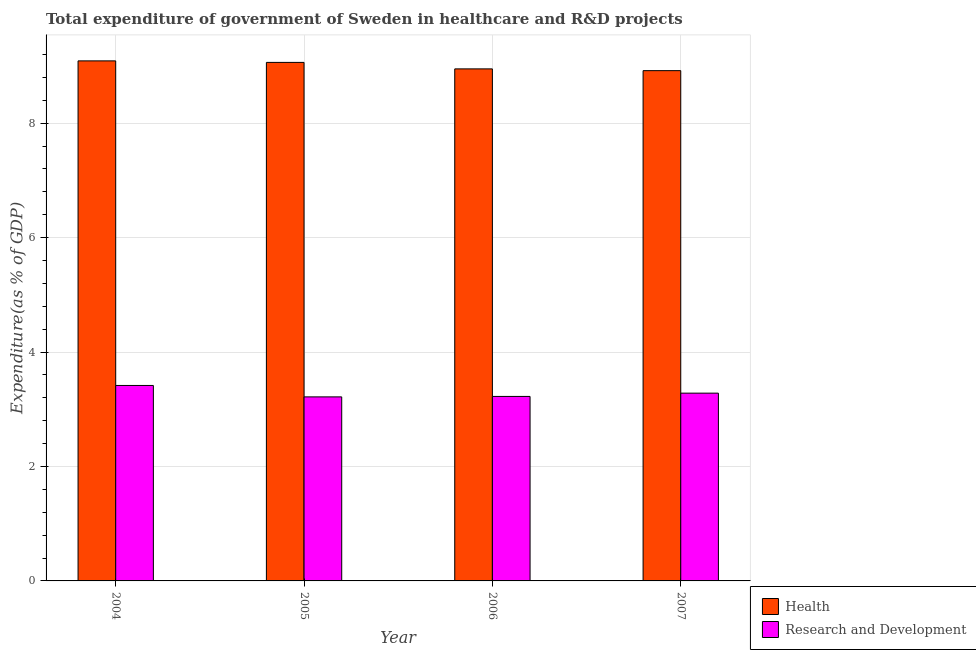How many different coloured bars are there?
Make the answer very short. 2. How many groups of bars are there?
Make the answer very short. 4. Are the number of bars per tick equal to the number of legend labels?
Provide a succinct answer. Yes. How many bars are there on the 3rd tick from the left?
Your response must be concise. 2. How many bars are there on the 4th tick from the right?
Provide a short and direct response. 2. What is the label of the 3rd group of bars from the left?
Offer a very short reply. 2006. In how many cases, is the number of bars for a given year not equal to the number of legend labels?
Give a very brief answer. 0. What is the expenditure in healthcare in 2005?
Make the answer very short. 9.06. Across all years, what is the maximum expenditure in healthcare?
Offer a terse response. 9.09. Across all years, what is the minimum expenditure in healthcare?
Ensure brevity in your answer.  8.92. In which year was the expenditure in r&d maximum?
Make the answer very short. 2004. In which year was the expenditure in healthcare minimum?
Your answer should be compact. 2007. What is the total expenditure in r&d in the graph?
Provide a short and direct response. 13.14. What is the difference between the expenditure in r&d in 2004 and that in 2006?
Make the answer very short. 0.19. What is the difference between the expenditure in healthcare in 2006 and the expenditure in r&d in 2004?
Give a very brief answer. -0.14. What is the average expenditure in healthcare per year?
Keep it short and to the point. 9. In how many years, is the expenditure in r&d greater than 5.6 %?
Your answer should be compact. 0. What is the ratio of the expenditure in healthcare in 2004 to that in 2006?
Give a very brief answer. 1.02. Is the difference between the expenditure in healthcare in 2005 and 2007 greater than the difference between the expenditure in r&d in 2005 and 2007?
Provide a succinct answer. No. What is the difference between the highest and the second highest expenditure in r&d?
Offer a very short reply. 0.13. What is the difference between the highest and the lowest expenditure in r&d?
Offer a terse response. 0.2. What does the 2nd bar from the left in 2004 represents?
Your answer should be compact. Research and Development. What does the 2nd bar from the right in 2007 represents?
Provide a succinct answer. Health. How many bars are there?
Make the answer very short. 8. How many years are there in the graph?
Provide a short and direct response. 4. What is the difference between two consecutive major ticks on the Y-axis?
Your answer should be compact. 2. Are the values on the major ticks of Y-axis written in scientific E-notation?
Offer a terse response. No. How many legend labels are there?
Give a very brief answer. 2. How are the legend labels stacked?
Your answer should be compact. Vertical. What is the title of the graph?
Your answer should be compact. Total expenditure of government of Sweden in healthcare and R&D projects. What is the label or title of the Y-axis?
Provide a short and direct response. Expenditure(as % of GDP). What is the Expenditure(as % of GDP) in Health in 2004?
Offer a terse response. 9.09. What is the Expenditure(as % of GDP) in Research and Development in 2004?
Your answer should be very brief. 3.42. What is the Expenditure(as % of GDP) of Health in 2005?
Give a very brief answer. 9.06. What is the Expenditure(as % of GDP) of Research and Development in 2005?
Offer a very short reply. 3.22. What is the Expenditure(as % of GDP) of Health in 2006?
Provide a short and direct response. 8.95. What is the Expenditure(as % of GDP) in Research and Development in 2006?
Offer a terse response. 3.22. What is the Expenditure(as % of GDP) of Health in 2007?
Offer a terse response. 8.92. What is the Expenditure(as % of GDP) in Research and Development in 2007?
Ensure brevity in your answer.  3.28. Across all years, what is the maximum Expenditure(as % of GDP) of Health?
Your answer should be compact. 9.09. Across all years, what is the maximum Expenditure(as % of GDP) of Research and Development?
Offer a very short reply. 3.42. Across all years, what is the minimum Expenditure(as % of GDP) in Health?
Give a very brief answer. 8.92. Across all years, what is the minimum Expenditure(as % of GDP) in Research and Development?
Offer a terse response. 3.22. What is the total Expenditure(as % of GDP) in Health in the graph?
Provide a succinct answer. 36.01. What is the total Expenditure(as % of GDP) in Research and Development in the graph?
Ensure brevity in your answer.  13.14. What is the difference between the Expenditure(as % of GDP) in Health in 2004 and that in 2005?
Offer a terse response. 0.03. What is the difference between the Expenditure(as % of GDP) of Research and Development in 2004 and that in 2005?
Provide a succinct answer. 0.2. What is the difference between the Expenditure(as % of GDP) in Health in 2004 and that in 2006?
Provide a short and direct response. 0.14. What is the difference between the Expenditure(as % of GDP) of Research and Development in 2004 and that in 2006?
Your answer should be very brief. 0.19. What is the difference between the Expenditure(as % of GDP) of Health in 2004 and that in 2007?
Provide a succinct answer. 0.17. What is the difference between the Expenditure(as % of GDP) of Research and Development in 2004 and that in 2007?
Keep it short and to the point. 0.13. What is the difference between the Expenditure(as % of GDP) in Health in 2005 and that in 2006?
Your response must be concise. 0.11. What is the difference between the Expenditure(as % of GDP) of Research and Development in 2005 and that in 2006?
Provide a succinct answer. -0.01. What is the difference between the Expenditure(as % of GDP) of Health in 2005 and that in 2007?
Make the answer very short. 0.14. What is the difference between the Expenditure(as % of GDP) in Research and Development in 2005 and that in 2007?
Your response must be concise. -0.07. What is the difference between the Expenditure(as % of GDP) of Health in 2006 and that in 2007?
Ensure brevity in your answer.  0.03. What is the difference between the Expenditure(as % of GDP) of Research and Development in 2006 and that in 2007?
Provide a succinct answer. -0.06. What is the difference between the Expenditure(as % of GDP) in Health in 2004 and the Expenditure(as % of GDP) in Research and Development in 2005?
Offer a very short reply. 5.87. What is the difference between the Expenditure(as % of GDP) in Health in 2004 and the Expenditure(as % of GDP) in Research and Development in 2006?
Make the answer very short. 5.86. What is the difference between the Expenditure(as % of GDP) in Health in 2004 and the Expenditure(as % of GDP) in Research and Development in 2007?
Keep it short and to the point. 5.81. What is the difference between the Expenditure(as % of GDP) of Health in 2005 and the Expenditure(as % of GDP) of Research and Development in 2006?
Provide a succinct answer. 5.84. What is the difference between the Expenditure(as % of GDP) of Health in 2005 and the Expenditure(as % of GDP) of Research and Development in 2007?
Keep it short and to the point. 5.78. What is the difference between the Expenditure(as % of GDP) of Health in 2006 and the Expenditure(as % of GDP) of Research and Development in 2007?
Give a very brief answer. 5.67. What is the average Expenditure(as % of GDP) of Health per year?
Your answer should be compact. 9. What is the average Expenditure(as % of GDP) in Research and Development per year?
Provide a succinct answer. 3.28. In the year 2004, what is the difference between the Expenditure(as % of GDP) in Health and Expenditure(as % of GDP) in Research and Development?
Give a very brief answer. 5.67. In the year 2005, what is the difference between the Expenditure(as % of GDP) of Health and Expenditure(as % of GDP) of Research and Development?
Keep it short and to the point. 5.85. In the year 2006, what is the difference between the Expenditure(as % of GDP) of Health and Expenditure(as % of GDP) of Research and Development?
Provide a short and direct response. 5.72. In the year 2007, what is the difference between the Expenditure(as % of GDP) in Health and Expenditure(as % of GDP) in Research and Development?
Provide a short and direct response. 5.64. What is the ratio of the Expenditure(as % of GDP) in Health in 2004 to that in 2005?
Offer a very short reply. 1. What is the ratio of the Expenditure(as % of GDP) of Research and Development in 2004 to that in 2005?
Your response must be concise. 1.06. What is the ratio of the Expenditure(as % of GDP) in Health in 2004 to that in 2006?
Ensure brevity in your answer.  1.02. What is the ratio of the Expenditure(as % of GDP) of Research and Development in 2004 to that in 2006?
Offer a very short reply. 1.06. What is the ratio of the Expenditure(as % of GDP) in Health in 2004 to that in 2007?
Your response must be concise. 1.02. What is the ratio of the Expenditure(as % of GDP) of Research and Development in 2004 to that in 2007?
Provide a succinct answer. 1.04. What is the ratio of the Expenditure(as % of GDP) of Health in 2005 to that in 2006?
Ensure brevity in your answer.  1.01. What is the ratio of the Expenditure(as % of GDP) in Health in 2005 to that in 2007?
Give a very brief answer. 1.02. What is the ratio of the Expenditure(as % of GDP) in Research and Development in 2005 to that in 2007?
Your answer should be compact. 0.98. What is the ratio of the Expenditure(as % of GDP) in Health in 2006 to that in 2007?
Make the answer very short. 1. What is the ratio of the Expenditure(as % of GDP) of Research and Development in 2006 to that in 2007?
Offer a terse response. 0.98. What is the difference between the highest and the second highest Expenditure(as % of GDP) in Health?
Offer a terse response. 0.03. What is the difference between the highest and the second highest Expenditure(as % of GDP) in Research and Development?
Give a very brief answer. 0.13. What is the difference between the highest and the lowest Expenditure(as % of GDP) of Health?
Keep it short and to the point. 0.17. What is the difference between the highest and the lowest Expenditure(as % of GDP) in Research and Development?
Give a very brief answer. 0.2. 